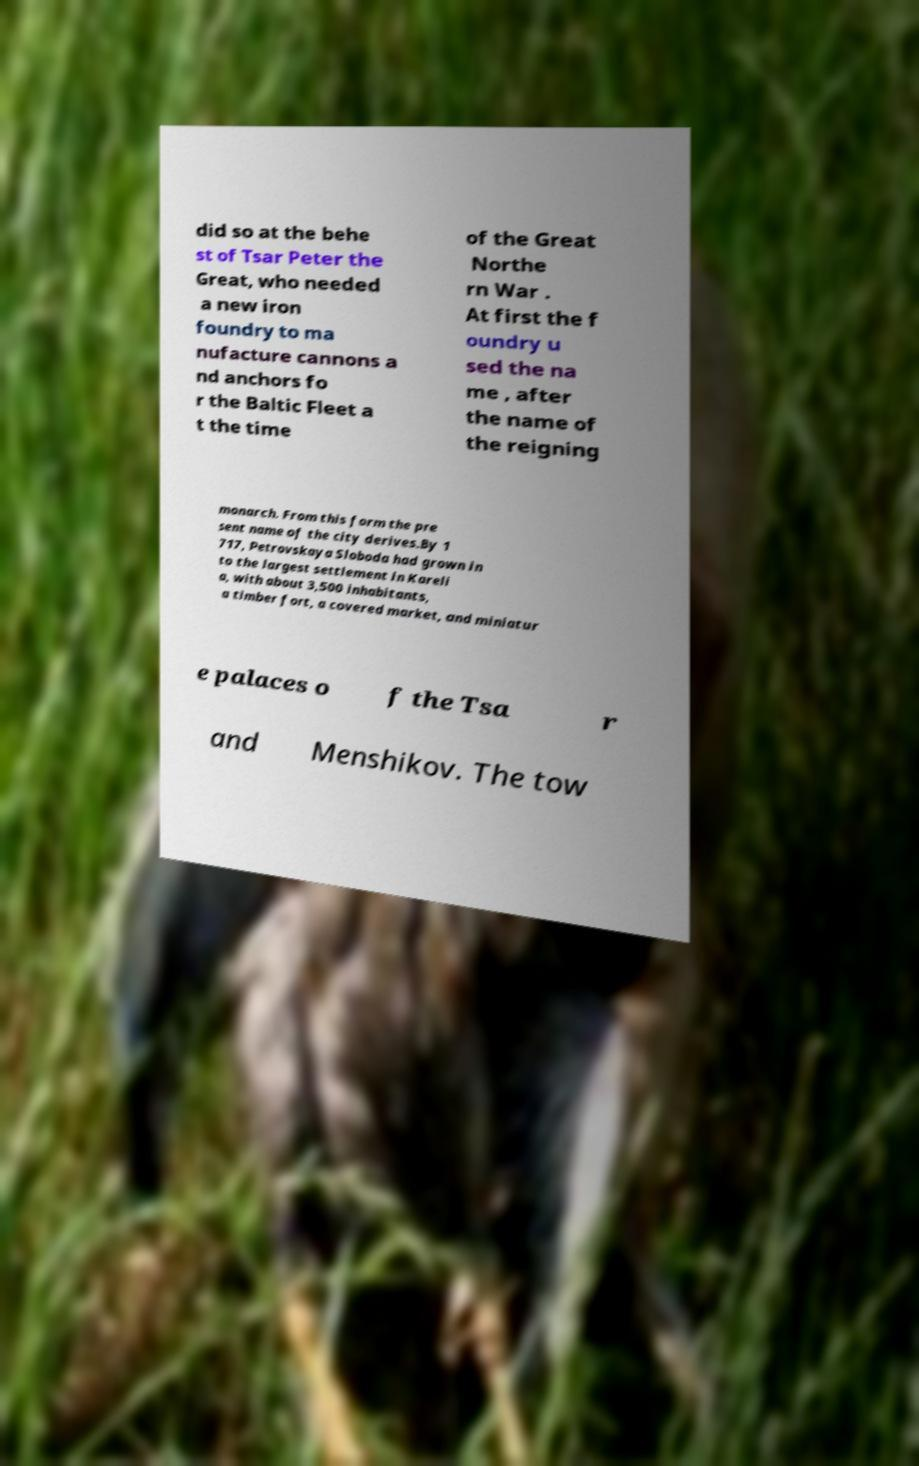There's text embedded in this image that I need extracted. Can you transcribe it verbatim? did so at the behe st of Tsar Peter the Great, who needed a new iron foundry to ma nufacture cannons a nd anchors fo r the Baltic Fleet a t the time of the Great Northe rn War . At first the f oundry u sed the na me , after the name of the reigning monarch. From this form the pre sent name of the city derives.By 1 717, Petrovskaya Sloboda had grown in to the largest settlement in Kareli a, with about 3,500 inhabitants, a timber fort, a covered market, and miniatur e palaces o f the Tsa r and Menshikov. The tow 